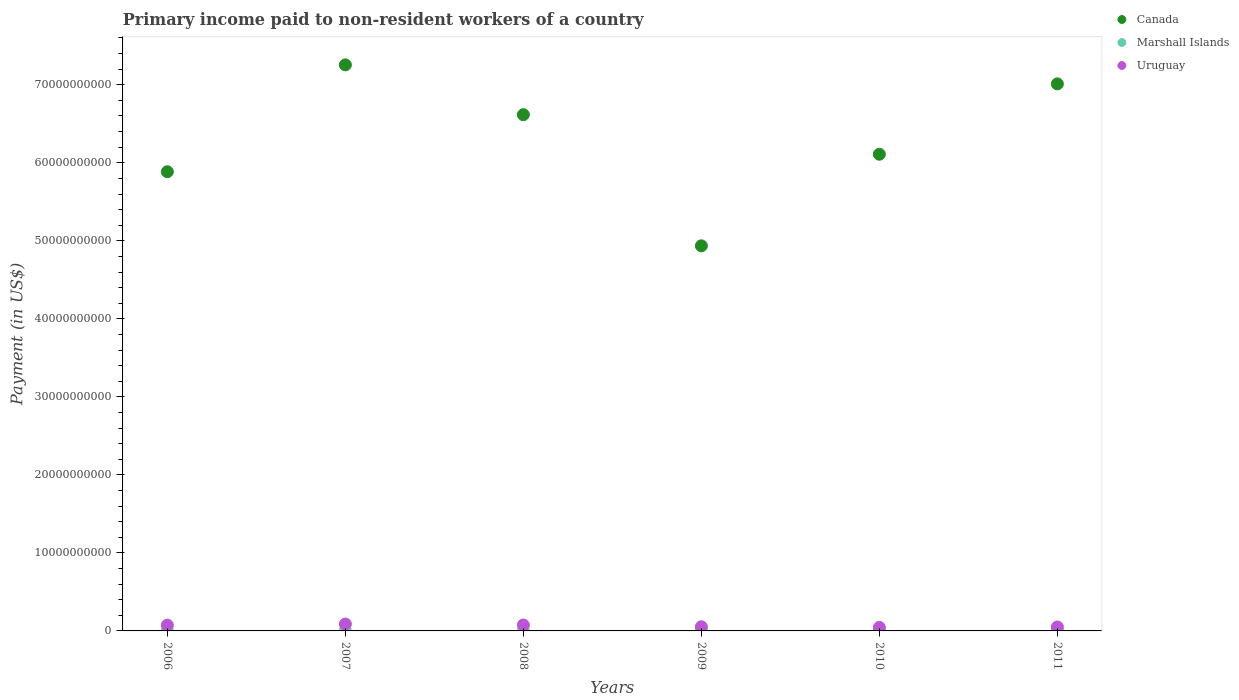Is the number of dotlines equal to the number of legend labels?
Give a very brief answer. Yes. What is the amount paid to workers in Canada in 2006?
Your response must be concise. 5.89e+1. Across all years, what is the maximum amount paid to workers in Marshall Islands?
Your answer should be very brief. 5.65e+07. Across all years, what is the minimum amount paid to workers in Canada?
Your answer should be very brief. 4.94e+1. In which year was the amount paid to workers in Uruguay minimum?
Keep it short and to the point. 2010. What is the total amount paid to workers in Marshall Islands in the graph?
Your response must be concise. 3.26e+08. What is the difference between the amount paid to workers in Marshall Islands in 2010 and that in 2011?
Offer a very short reply. -5.94e+06. What is the difference between the amount paid to workers in Canada in 2011 and the amount paid to workers in Uruguay in 2009?
Give a very brief answer. 6.96e+1. What is the average amount paid to workers in Uruguay per year?
Keep it short and to the point. 6.46e+08. In the year 2011, what is the difference between the amount paid to workers in Marshall Islands and amount paid to workers in Uruguay?
Your response must be concise. -4.49e+08. What is the ratio of the amount paid to workers in Uruguay in 2006 to that in 2010?
Offer a very short reply. 1.63. Is the amount paid to workers in Marshall Islands in 2010 less than that in 2011?
Your answer should be very brief. Yes. Is the difference between the amount paid to workers in Marshall Islands in 2009 and 2011 greater than the difference between the amount paid to workers in Uruguay in 2009 and 2011?
Ensure brevity in your answer.  No. What is the difference between the highest and the second highest amount paid to workers in Uruguay?
Make the answer very short. 1.28e+08. What is the difference between the highest and the lowest amount paid to workers in Canada?
Provide a succinct answer. 2.32e+1. Is the sum of the amount paid to workers in Marshall Islands in 2006 and 2007 greater than the maximum amount paid to workers in Uruguay across all years?
Your response must be concise. No. Does the amount paid to workers in Canada monotonically increase over the years?
Keep it short and to the point. No. Is the amount paid to workers in Uruguay strictly greater than the amount paid to workers in Marshall Islands over the years?
Provide a succinct answer. Yes. What is the difference between two consecutive major ticks on the Y-axis?
Provide a succinct answer. 1.00e+1. Does the graph contain any zero values?
Give a very brief answer. No. Does the graph contain grids?
Keep it short and to the point. No. How are the legend labels stacked?
Give a very brief answer. Vertical. What is the title of the graph?
Offer a terse response. Primary income paid to non-resident workers of a country. Does "Argentina" appear as one of the legend labels in the graph?
Provide a short and direct response. No. What is the label or title of the Y-axis?
Keep it short and to the point. Payment (in US$). What is the Payment (in US$) in Canada in 2006?
Make the answer very short. 5.89e+1. What is the Payment (in US$) of Marshall Islands in 2006?
Give a very brief answer. 5.57e+07. What is the Payment (in US$) of Uruguay in 2006?
Provide a succinct answer. 7.42e+08. What is the Payment (in US$) of Canada in 2007?
Make the answer very short. 7.26e+1. What is the Payment (in US$) in Marshall Islands in 2007?
Offer a very short reply. 5.65e+07. What is the Payment (in US$) in Uruguay in 2007?
Offer a very short reply. 8.85e+08. What is the Payment (in US$) in Canada in 2008?
Provide a short and direct response. 6.62e+1. What is the Payment (in US$) of Marshall Islands in 2008?
Make the answer very short. 5.48e+07. What is the Payment (in US$) in Uruguay in 2008?
Your response must be concise. 7.57e+08. What is the Payment (in US$) in Canada in 2009?
Your response must be concise. 4.94e+1. What is the Payment (in US$) of Marshall Islands in 2009?
Offer a terse response. 5.29e+07. What is the Payment (in US$) in Uruguay in 2009?
Keep it short and to the point. 5.32e+08. What is the Payment (in US$) in Canada in 2010?
Offer a very short reply. 6.11e+1. What is the Payment (in US$) in Marshall Islands in 2010?
Make the answer very short. 5.02e+07. What is the Payment (in US$) in Uruguay in 2010?
Ensure brevity in your answer.  4.55e+08. What is the Payment (in US$) in Canada in 2011?
Your answer should be compact. 7.01e+1. What is the Payment (in US$) in Marshall Islands in 2011?
Offer a very short reply. 5.61e+07. What is the Payment (in US$) of Uruguay in 2011?
Your answer should be very brief. 5.05e+08. Across all years, what is the maximum Payment (in US$) in Canada?
Provide a short and direct response. 7.26e+1. Across all years, what is the maximum Payment (in US$) in Marshall Islands?
Ensure brevity in your answer.  5.65e+07. Across all years, what is the maximum Payment (in US$) in Uruguay?
Ensure brevity in your answer.  8.85e+08. Across all years, what is the minimum Payment (in US$) in Canada?
Keep it short and to the point. 4.94e+1. Across all years, what is the minimum Payment (in US$) of Marshall Islands?
Provide a short and direct response. 5.02e+07. Across all years, what is the minimum Payment (in US$) of Uruguay?
Provide a succinct answer. 4.55e+08. What is the total Payment (in US$) of Canada in the graph?
Your answer should be compact. 3.78e+11. What is the total Payment (in US$) of Marshall Islands in the graph?
Offer a very short reply. 3.26e+08. What is the total Payment (in US$) in Uruguay in the graph?
Your response must be concise. 3.88e+09. What is the difference between the Payment (in US$) of Canada in 2006 and that in 2007?
Ensure brevity in your answer.  -1.37e+1. What is the difference between the Payment (in US$) of Marshall Islands in 2006 and that in 2007?
Keep it short and to the point. -8.64e+05. What is the difference between the Payment (in US$) of Uruguay in 2006 and that in 2007?
Offer a terse response. -1.44e+08. What is the difference between the Payment (in US$) of Canada in 2006 and that in 2008?
Offer a very short reply. -7.31e+09. What is the difference between the Payment (in US$) of Marshall Islands in 2006 and that in 2008?
Provide a short and direct response. 9.03e+05. What is the difference between the Payment (in US$) of Uruguay in 2006 and that in 2008?
Your answer should be very brief. -1.60e+07. What is the difference between the Payment (in US$) of Canada in 2006 and that in 2009?
Make the answer very short. 9.50e+09. What is the difference between the Payment (in US$) in Marshall Islands in 2006 and that in 2009?
Your response must be concise. 2.78e+06. What is the difference between the Payment (in US$) of Uruguay in 2006 and that in 2009?
Offer a terse response. 2.10e+08. What is the difference between the Payment (in US$) in Canada in 2006 and that in 2010?
Keep it short and to the point. -2.24e+09. What is the difference between the Payment (in US$) of Marshall Islands in 2006 and that in 2010?
Make the answer very short. 5.46e+06. What is the difference between the Payment (in US$) in Uruguay in 2006 and that in 2010?
Give a very brief answer. 2.87e+08. What is the difference between the Payment (in US$) of Canada in 2006 and that in 2011?
Keep it short and to the point. -1.13e+1. What is the difference between the Payment (in US$) of Marshall Islands in 2006 and that in 2011?
Your response must be concise. -4.78e+05. What is the difference between the Payment (in US$) of Uruguay in 2006 and that in 2011?
Your response must be concise. 2.37e+08. What is the difference between the Payment (in US$) in Canada in 2007 and that in 2008?
Offer a terse response. 6.39e+09. What is the difference between the Payment (in US$) of Marshall Islands in 2007 and that in 2008?
Provide a short and direct response. 1.77e+06. What is the difference between the Payment (in US$) of Uruguay in 2007 and that in 2008?
Your answer should be very brief. 1.28e+08. What is the difference between the Payment (in US$) in Canada in 2007 and that in 2009?
Provide a short and direct response. 2.32e+1. What is the difference between the Payment (in US$) of Marshall Islands in 2007 and that in 2009?
Your response must be concise. 3.65e+06. What is the difference between the Payment (in US$) in Uruguay in 2007 and that in 2009?
Your answer should be compact. 3.53e+08. What is the difference between the Payment (in US$) of Canada in 2007 and that in 2010?
Provide a succinct answer. 1.15e+1. What is the difference between the Payment (in US$) of Marshall Islands in 2007 and that in 2010?
Your answer should be very brief. 6.32e+06. What is the difference between the Payment (in US$) in Uruguay in 2007 and that in 2010?
Keep it short and to the point. 4.30e+08. What is the difference between the Payment (in US$) in Canada in 2007 and that in 2011?
Provide a short and direct response. 2.44e+09. What is the difference between the Payment (in US$) in Marshall Islands in 2007 and that in 2011?
Provide a short and direct response. 3.85e+05. What is the difference between the Payment (in US$) in Uruguay in 2007 and that in 2011?
Give a very brief answer. 3.80e+08. What is the difference between the Payment (in US$) in Canada in 2008 and that in 2009?
Offer a very short reply. 1.68e+1. What is the difference between the Payment (in US$) of Marshall Islands in 2008 and that in 2009?
Your response must be concise. 1.88e+06. What is the difference between the Payment (in US$) in Uruguay in 2008 and that in 2009?
Your answer should be compact. 2.26e+08. What is the difference between the Payment (in US$) in Canada in 2008 and that in 2010?
Ensure brevity in your answer.  5.07e+09. What is the difference between the Payment (in US$) in Marshall Islands in 2008 and that in 2010?
Keep it short and to the point. 4.56e+06. What is the difference between the Payment (in US$) of Uruguay in 2008 and that in 2010?
Keep it short and to the point. 3.03e+08. What is the difference between the Payment (in US$) in Canada in 2008 and that in 2011?
Offer a terse response. -3.95e+09. What is the difference between the Payment (in US$) of Marshall Islands in 2008 and that in 2011?
Keep it short and to the point. -1.38e+06. What is the difference between the Payment (in US$) in Uruguay in 2008 and that in 2011?
Your answer should be very brief. 2.53e+08. What is the difference between the Payment (in US$) in Canada in 2009 and that in 2010?
Offer a terse response. -1.17e+1. What is the difference between the Payment (in US$) of Marshall Islands in 2009 and that in 2010?
Keep it short and to the point. 2.68e+06. What is the difference between the Payment (in US$) of Uruguay in 2009 and that in 2010?
Give a very brief answer. 7.70e+07. What is the difference between the Payment (in US$) in Canada in 2009 and that in 2011?
Your answer should be very brief. -2.08e+1. What is the difference between the Payment (in US$) of Marshall Islands in 2009 and that in 2011?
Your answer should be compact. -3.26e+06. What is the difference between the Payment (in US$) of Uruguay in 2009 and that in 2011?
Give a very brief answer. 2.67e+07. What is the difference between the Payment (in US$) of Canada in 2010 and that in 2011?
Keep it short and to the point. -9.02e+09. What is the difference between the Payment (in US$) in Marshall Islands in 2010 and that in 2011?
Your answer should be very brief. -5.94e+06. What is the difference between the Payment (in US$) of Uruguay in 2010 and that in 2011?
Your response must be concise. -5.03e+07. What is the difference between the Payment (in US$) in Canada in 2006 and the Payment (in US$) in Marshall Islands in 2007?
Keep it short and to the point. 5.88e+1. What is the difference between the Payment (in US$) in Canada in 2006 and the Payment (in US$) in Uruguay in 2007?
Offer a very short reply. 5.80e+1. What is the difference between the Payment (in US$) of Marshall Islands in 2006 and the Payment (in US$) of Uruguay in 2007?
Your response must be concise. -8.29e+08. What is the difference between the Payment (in US$) of Canada in 2006 and the Payment (in US$) of Marshall Islands in 2008?
Give a very brief answer. 5.88e+1. What is the difference between the Payment (in US$) in Canada in 2006 and the Payment (in US$) in Uruguay in 2008?
Give a very brief answer. 5.81e+1. What is the difference between the Payment (in US$) of Marshall Islands in 2006 and the Payment (in US$) of Uruguay in 2008?
Keep it short and to the point. -7.02e+08. What is the difference between the Payment (in US$) in Canada in 2006 and the Payment (in US$) in Marshall Islands in 2009?
Ensure brevity in your answer.  5.88e+1. What is the difference between the Payment (in US$) of Canada in 2006 and the Payment (in US$) of Uruguay in 2009?
Your answer should be compact. 5.83e+1. What is the difference between the Payment (in US$) of Marshall Islands in 2006 and the Payment (in US$) of Uruguay in 2009?
Ensure brevity in your answer.  -4.76e+08. What is the difference between the Payment (in US$) of Canada in 2006 and the Payment (in US$) of Marshall Islands in 2010?
Your answer should be compact. 5.88e+1. What is the difference between the Payment (in US$) in Canada in 2006 and the Payment (in US$) in Uruguay in 2010?
Keep it short and to the point. 5.84e+1. What is the difference between the Payment (in US$) of Marshall Islands in 2006 and the Payment (in US$) of Uruguay in 2010?
Offer a very short reply. -3.99e+08. What is the difference between the Payment (in US$) in Canada in 2006 and the Payment (in US$) in Marshall Islands in 2011?
Offer a very short reply. 5.88e+1. What is the difference between the Payment (in US$) in Canada in 2006 and the Payment (in US$) in Uruguay in 2011?
Offer a terse response. 5.84e+1. What is the difference between the Payment (in US$) of Marshall Islands in 2006 and the Payment (in US$) of Uruguay in 2011?
Your answer should be very brief. -4.49e+08. What is the difference between the Payment (in US$) of Canada in 2007 and the Payment (in US$) of Marshall Islands in 2008?
Offer a very short reply. 7.25e+1. What is the difference between the Payment (in US$) of Canada in 2007 and the Payment (in US$) of Uruguay in 2008?
Provide a succinct answer. 7.18e+1. What is the difference between the Payment (in US$) of Marshall Islands in 2007 and the Payment (in US$) of Uruguay in 2008?
Provide a succinct answer. -7.01e+08. What is the difference between the Payment (in US$) of Canada in 2007 and the Payment (in US$) of Marshall Islands in 2009?
Provide a succinct answer. 7.25e+1. What is the difference between the Payment (in US$) of Canada in 2007 and the Payment (in US$) of Uruguay in 2009?
Provide a succinct answer. 7.20e+1. What is the difference between the Payment (in US$) in Marshall Islands in 2007 and the Payment (in US$) in Uruguay in 2009?
Offer a very short reply. -4.75e+08. What is the difference between the Payment (in US$) in Canada in 2007 and the Payment (in US$) in Marshall Islands in 2010?
Provide a short and direct response. 7.25e+1. What is the difference between the Payment (in US$) in Canada in 2007 and the Payment (in US$) in Uruguay in 2010?
Provide a short and direct response. 7.21e+1. What is the difference between the Payment (in US$) in Marshall Islands in 2007 and the Payment (in US$) in Uruguay in 2010?
Your response must be concise. -3.98e+08. What is the difference between the Payment (in US$) of Canada in 2007 and the Payment (in US$) of Marshall Islands in 2011?
Your response must be concise. 7.25e+1. What is the difference between the Payment (in US$) in Canada in 2007 and the Payment (in US$) in Uruguay in 2011?
Offer a terse response. 7.20e+1. What is the difference between the Payment (in US$) in Marshall Islands in 2007 and the Payment (in US$) in Uruguay in 2011?
Provide a short and direct response. -4.48e+08. What is the difference between the Payment (in US$) in Canada in 2008 and the Payment (in US$) in Marshall Islands in 2009?
Offer a very short reply. 6.61e+1. What is the difference between the Payment (in US$) of Canada in 2008 and the Payment (in US$) of Uruguay in 2009?
Provide a short and direct response. 6.56e+1. What is the difference between the Payment (in US$) in Marshall Islands in 2008 and the Payment (in US$) in Uruguay in 2009?
Your answer should be compact. -4.77e+08. What is the difference between the Payment (in US$) of Canada in 2008 and the Payment (in US$) of Marshall Islands in 2010?
Keep it short and to the point. 6.61e+1. What is the difference between the Payment (in US$) in Canada in 2008 and the Payment (in US$) in Uruguay in 2010?
Keep it short and to the point. 6.57e+1. What is the difference between the Payment (in US$) in Marshall Islands in 2008 and the Payment (in US$) in Uruguay in 2010?
Provide a succinct answer. -4.00e+08. What is the difference between the Payment (in US$) in Canada in 2008 and the Payment (in US$) in Marshall Islands in 2011?
Keep it short and to the point. 6.61e+1. What is the difference between the Payment (in US$) of Canada in 2008 and the Payment (in US$) of Uruguay in 2011?
Your answer should be compact. 6.57e+1. What is the difference between the Payment (in US$) in Marshall Islands in 2008 and the Payment (in US$) in Uruguay in 2011?
Your response must be concise. -4.50e+08. What is the difference between the Payment (in US$) in Canada in 2009 and the Payment (in US$) in Marshall Islands in 2010?
Ensure brevity in your answer.  4.93e+1. What is the difference between the Payment (in US$) of Canada in 2009 and the Payment (in US$) of Uruguay in 2010?
Your response must be concise. 4.89e+1. What is the difference between the Payment (in US$) of Marshall Islands in 2009 and the Payment (in US$) of Uruguay in 2010?
Ensure brevity in your answer.  -4.02e+08. What is the difference between the Payment (in US$) of Canada in 2009 and the Payment (in US$) of Marshall Islands in 2011?
Ensure brevity in your answer.  4.93e+1. What is the difference between the Payment (in US$) of Canada in 2009 and the Payment (in US$) of Uruguay in 2011?
Offer a terse response. 4.89e+1. What is the difference between the Payment (in US$) of Marshall Islands in 2009 and the Payment (in US$) of Uruguay in 2011?
Offer a terse response. -4.52e+08. What is the difference between the Payment (in US$) of Canada in 2010 and the Payment (in US$) of Marshall Islands in 2011?
Your answer should be very brief. 6.10e+1. What is the difference between the Payment (in US$) in Canada in 2010 and the Payment (in US$) in Uruguay in 2011?
Your answer should be compact. 6.06e+1. What is the difference between the Payment (in US$) of Marshall Islands in 2010 and the Payment (in US$) of Uruguay in 2011?
Your answer should be compact. -4.55e+08. What is the average Payment (in US$) of Canada per year?
Your answer should be compact. 6.30e+1. What is the average Payment (in US$) in Marshall Islands per year?
Make the answer very short. 5.44e+07. What is the average Payment (in US$) in Uruguay per year?
Provide a short and direct response. 6.46e+08. In the year 2006, what is the difference between the Payment (in US$) in Canada and Payment (in US$) in Marshall Islands?
Provide a succinct answer. 5.88e+1. In the year 2006, what is the difference between the Payment (in US$) in Canada and Payment (in US$) in Uruguay?
Make the answer very short. 5.81e+1. In the year 2006, what is the difference between the Payment (in US$) in Marshall Islands and Payment (in US$) in Uruguay?
Give a very brief answer. -6.86e+08. In the year 2007, what is the difference between the Payment (in US$) of Canada and Payment (in US$) of Marshall Islands?
Your response must be concise. 7.25e+1. In the year 2007, what is the difference between the Payment (in US$) of Canada and Payment (in US$) of Uruguay?
Your response must be concise. 7.17e+1. In the year 2007, what is the difference between the Payment (in US$) of Marshall Islands and Payment (in US$) of Uruguay?
Give a very brief answer. -8.29e+08. In the year 2008, what is the difference between the Payment (in US$) of Canada and Payment (in US$) of Marshall Islands?
Your answer should be compact. 6.61e+1. In the year 2008, what is the difference between the Payment (in US$) of Canada and Payment (in US$) of Uruguay?
Keep it short and to the point. 6.54e+1. In the year 2008, what is the difference between the Payment (in US$) in Marshall Islands and Payment (in US$) in Uruguay?
Offer a terse response. -7.03e+08. In the year 2009, what is the difference between the Payment (in US$) in Canada and Payment (in US$) in Marshall Islands?
Your answer should be compact. 4.93e+1. In the year 2009, what is the difference between the Payment (in US$) in Canada and Payment (in US$) in Uruguay?
Your answer should be very brief. 4.88e+1. In the year 2009, what is the difference between the Payment (in US$) in Marshall Islands and Payment (in US$) in Uruguay?
Your answer should be very brief. -4.79e+08. In the year 2010, what is the difference between the Payment (in US$) of Canada and Payment (in US$) of Marshall Islands?
Ensure brevity in your answer.  6.10e+1. In the year 2010, what is the difference between the Payment (in US$) in Canada and Payment (in US$) in Uruguay?
Your answer should be compact. 6.06e+1. In the year 2010, what is the difference between the Payment (in US$) in Marshall Islands and Payment (in US$) in Uruguay?
Offer a very short reply. -4.04e+08. In the year 2011, what is the difference between the Payment (in US$) of Canada and Payment (in US$) of Marshall Islands?
Your answer should be very brief. 7.01e+1. In the year 2011, what is the difference between the Payment (in US$) in Canada and Payment (in US$) in Uruguay?
Give a very brief answer. 6.96e+1. In the year 2011, what is the difference between the Payment (in US$) of Marshall Islands and Payment (in US$) of Uruguay?
Offer a very short reply. -4.49e+08. What is the ratio of the Payment (in US$) in Canada in 2006 to that in 2007?
Provide a short and direct response. 0.81. What is the ratio of the Payment (in US$) in Marshall Islands in 2006 to that in 2007?
Your answer should be compact. 0.98. What is the ratio of the Payment (in US$) in Uruguay in 2006 to that in 2007?
Ensure brevity in your answer.  0.84. What is the ratio of the Payment (in US$) of Canada in 2006 to that in 2008?
Provide a succinct answer. 0.89. What is the ratio of the Payment (in US$) of Marshall Islands in 2006 to that in 2008?
Ensure brevity in your answer.  1.02. What is the ratio of the Payment (in US$) in Uruguay in 2006 to that in 2008?
Keep it short and to the point. 0.98. What is the ratio of the Payment (in US$) in Canada in 2006 to that in 2009?
Your answer should be very brief. 1.19. What is the ratio of the Payment (in US$) of Marshall Islands in 2006 to that in 2009?
Offer a very short reply. 1.05. What is the ratio of the Payment (in US$) of Uruguay in 2006 to that in 2009?
Make the answer very short. 1.39. What is the ratio of the Payment (in US$) of Canada in 2006 to that in 2010?
Your answer should be very brief. 0.96. What is the ratio of the Payment (in US$) in Marshall Islands in 2006 to that in 2010?
Ensure brevity in your answer.  1.11. What is the ratio of the Payment (in US$) in Uruguay in 2006 to that in 2010?
Provide a succinct answer. 1.63. What is the ratio of the Payment (in US$) in Canada in 2006 to that in 2011?
Your answer should be very brief. 0.84. What is the ratio of the Payment (in US$) in Marshall Islands in 2006 to that in 2011?
Your response must be concise. 0.99. What is the ratio of the Payment (in US$) of Uruguay in 2006 to that in 2011?
Your response must be concise. 1.47. What is the ratio of the Payment (in US$) in Canada in 2007 to that in 2008?
Make the answer very short. 1.1. What is the ratio of the Payment (in US$) in Marshall Islands in 2007 to that in 2008?
Your response must be concise. 1.03. What is the ratio of the Payment (in US$) of Uruguay in 2007 to that in 2008?
Give a very brief answer. 1.17. What is the ratio of the Payment (in US$) of Canada in 2007 to that in 2009?
Keep it short and to the point. 1.47. What is the ratio of the Payment (in US$) of Marshall Islands in 2007 to that in 2009?
Your answer should be very brief. 1.07. What is the ratio of the Payment (in US$) in Uruguay in 2007 to that in 2009?
Your response must be concise. 1.66. What is the ratio of the Payment (in US$) of Canada in 2007 to that in 2010?
Keep it short and to the point. 1.19. What is the ratio of the Payment (in US$) in Marshall Islands in 2007 to that in 2010?
Your answer should be compact. 1.13. What is the ratio of the Payment (in US$) in Uruguay in 2007 to that in 2010?
Your response must be concise. 1.95. What is the ratio of the Payment (in US$) of Canada in 2007 to that in 2011?
Your response must be concise. 1.03. What is the ratio of the Payment (in US$) of Uruguay in 2007 to that in 2011?
Make the answer very short. 1.75. What is the ratio of the Payment (in US$) of Canada in 2008 to that in 2009?
Provide a succinct answer. 1.34. What is the ratio of the Payment (in US$) in Marshall Islands in 2008 to that in 2009?
Provide a short and direct response. 1.04. What is the ratio of the Payment (in US$) in Uruguay in 2008 to that in 2009?
Your answer should be very brief. 1.43. What is the ratio of the Payment (in US$) of Canada in 2008 to that in 2010?
Give a very brief answer. 1.08. What is the ratio of the Payment (in US$) of Marshall Islands in 2008 to that in 2010?
Provide a short and direct response. 1.09. What is the ratio of the Payment (in US$) in Uruguay in 2008 to that in 2010?
Keep it short and to the point. 1.67. What is the ratio of the Payment (in US$) in Canada in 2008 to that in 2011?
Your answer should be compact. 0.94. What is the ratio of the Payment (in US$) of Marshall Islands in 2008 to that in 2011?
Make the answer very short. 0.98. What is the ratio of the Payment (in US$) of Uruguay in 2008 to that in 2011?
Provide a succinct answer. 1.5. What is the ratio of the Payment (in US$) in Canada in 2009 to that in 2010?
Your answer should be very brief. 0.81. What is the ratio of the Payment (in US$) in Marshall Islands in 2009 to that in 2010?
Make the answer very short. 1.05. What is the ratio of the Payment (in US$) in Uruguay in 2009 to that in 2010?
Offer a very short reply. 1.17. What is the ratio of the Payment (in US$) in Canada in 2009 to that in 2011?
Provide a short and direct response. 0.7. What is the ratio of the Payment (in US$) in Marshall Islands in 2009 to that in 2011?
Provide a short and direct response. 0.94. What is the ratio of the Payment (in US$) of Uruguay in 2009 to that in 2011?
Offer a very short reply. 1.05. What is the ratio of the Payment (in US$) of Canada in 2010 to that in 2011?
Provide a succinct answer. 0.87. What is the ratio of the Payment (in US$) of Marshall Islands in 2010 to that in 2011?
Offer a very short reply. 0.89. What is the ratio of the Payment (in US$) of Uruguay in 2010 to that in 2011?
Offer a terse response. 0.9. What is the difference between the highest and the second highest Payment (in US$) of Canada?
Offer a terse response. 2.44e+09. What is the difference between the highest and the second highest Payment (in US$) of Marshall Islands?
Make the answer very short. 3.85e+05. What is the difference between the highest and the second highest Payment (in US$) in Uruguay?
Ensure brevity in your answer.  1.28e+08. What is the difference between the highest and the lowest Payment (in US$) of Canada?
Your response must be concise. 2.32e+1. What is the difference between the highest and the lowest Payment (in US$) in Marshall Islands?
Make the answer very short. 6.32e+06. What is the difference between the highest and the lowest Payment (in US$) in Uruguay?
Ensure brevity in your answer.  4.30e+08. 